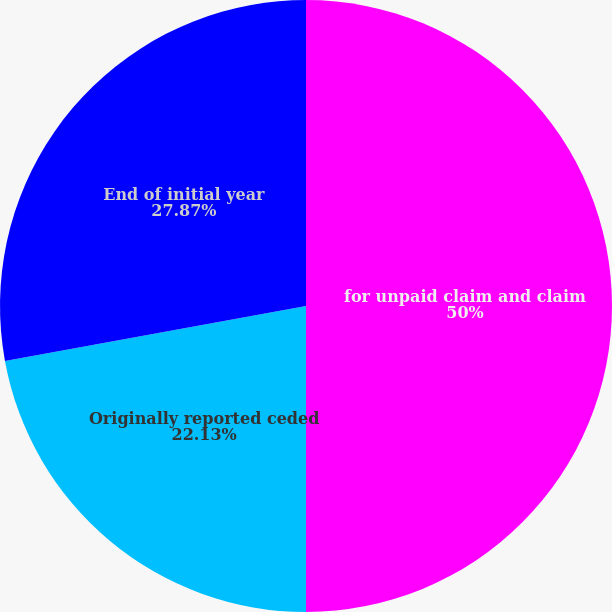Convert chart. <chart><loc_0><loc_0><loc_500><loc_500><pie_chart><fcel>for unpaid claim and claim<fcel>Originally reported ceded<fcel>End of initial year<nl><fcel>50.0%<fcel>22.13%<fcel>27.87%<nl></chart> 